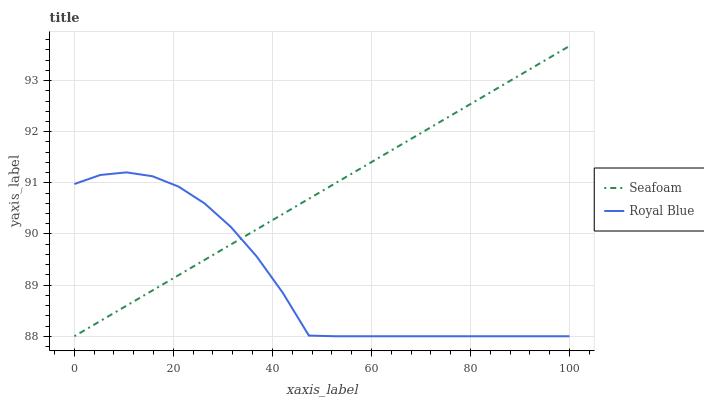Does Royal Blue have the minimum area under the curve?
Answer yes or no. Yes. Does Seafoam have the maximum area under the curve?
Answer yes or no. Yes. Does Seafoam have the minimum area under the curve?
Answer yes or no. No. Is Seafoam the smoothest?
Answer yes or no. Yes. Is Royal Blue the roughest?
Answer yes or no. Yes. Is Seafoam the roughest?
Answer yes or no. No. Does Royal Blue have the lowest value?
Answer yes or no. Yes. Does Seafoam have the highest value?
Answer yes or no. Yes. Does Seafoam intersect Royal Blue?
Answer yes or no. Yes. Is Seafoam less than Royal Blue?
Answer yes or no. No. Is Seafoam greater than Royal Blue?
Answer yes or no. No. 